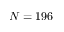<formula> <loc_0><loc_0><loc_500><loc_500>N = 1 9 6</formula> 